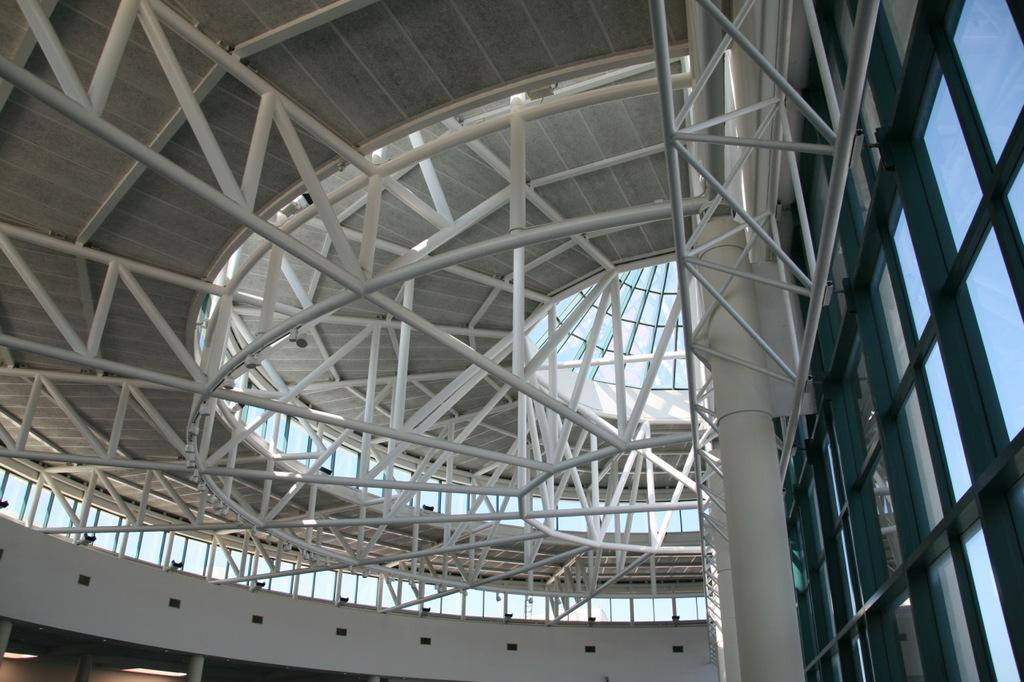Where is the location of the image? The image is inside a building. What structural elements can be seen in the image? There are rods, a roof, and a pillar visible in the image. What type of windows are present in the building? There are glass windows in the image. Can you describe the lighting conditions in the image? There are lights visible in the distance. Reasoning: Let's think step by step by step in order to produce the conversation. We start by identifying the location of the image, which is inside a building. Then, we describe the structural elements that are visible in the image, such as rods, a roof, and a pillar. Next, we focus on the windows, noting that they are made of glass. Finally, we mention the lighting conditions, which are indicated by the presence of lights in the distance. Absurd Question/Answer: What type of payment is required to enter the zoo in the image? There is no zoo present in the image; it is inside a building with structural elements and lighting conditions. 